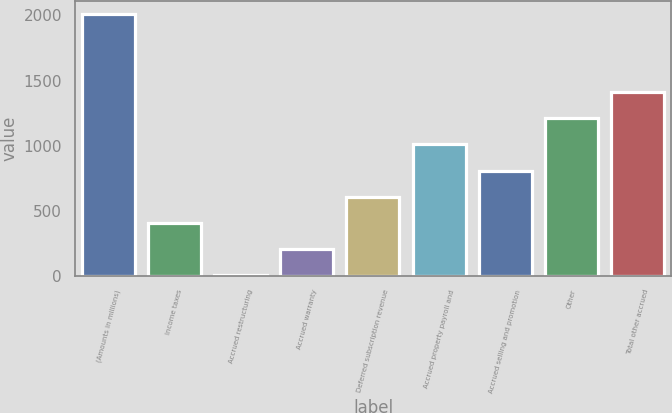<chart> <loc_0><loc_0><loc_500><loc_500><bar_chart><fcel>(Amounts in millions)<fcel>Income taxes<fcel>Accrued restructuring<fcel>Accrued warranty<fcel>Deferred subscription revenue<fcel>Accrued property payroll and<fcel>Accrued selling and promotion<fcel>Other<fcel>Total other accrued<nl><fcel>2012<fcel>408.16<fcel>7.2<fcel>207.68<fcel>608.64<fcel>1009.6<fcel>809.12<fcel>1210.08<fcel>1410.56<nl></chart> 